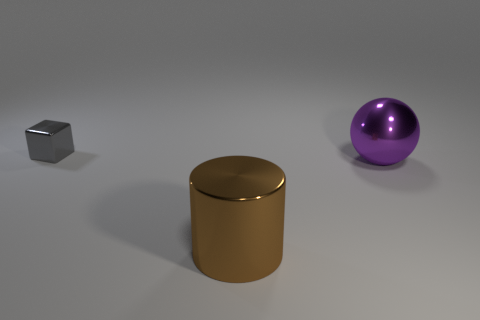Add 1 small gray shiny cubes. How many objects exist? 4 Subtract all blocks. How many objects are left? 2 Add 1 cylinders. How many cylinders are left? 2 Add 3 metal things. How many metal things exist? 6 Subtract 0 blue spheres. How many objects are left? 3 Subtract all yellow metallic things. Subtract all purple metallic spheres. How many objects are left? 2 